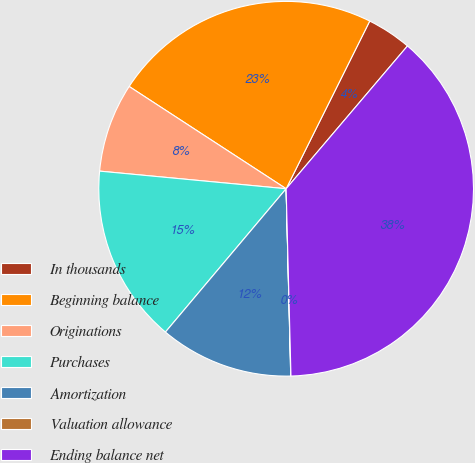Convert chart to OTSL. <chart><loc_0><loc_0><loc_500><loc_500><pie_chart><fcel>In thousands<fcel>Beginning balance<fcel>Originations<fcel>Purchases<fcel>Amortization<fcel>Valuation allowance<fcel>Ending balance net<nl><fcel>3.85%<fcel>23.17%<fcel>7.69%<fcel>15.36%<fcel>11.53%<fcel>0.02%<fcel>38.38%<nl></chart> 